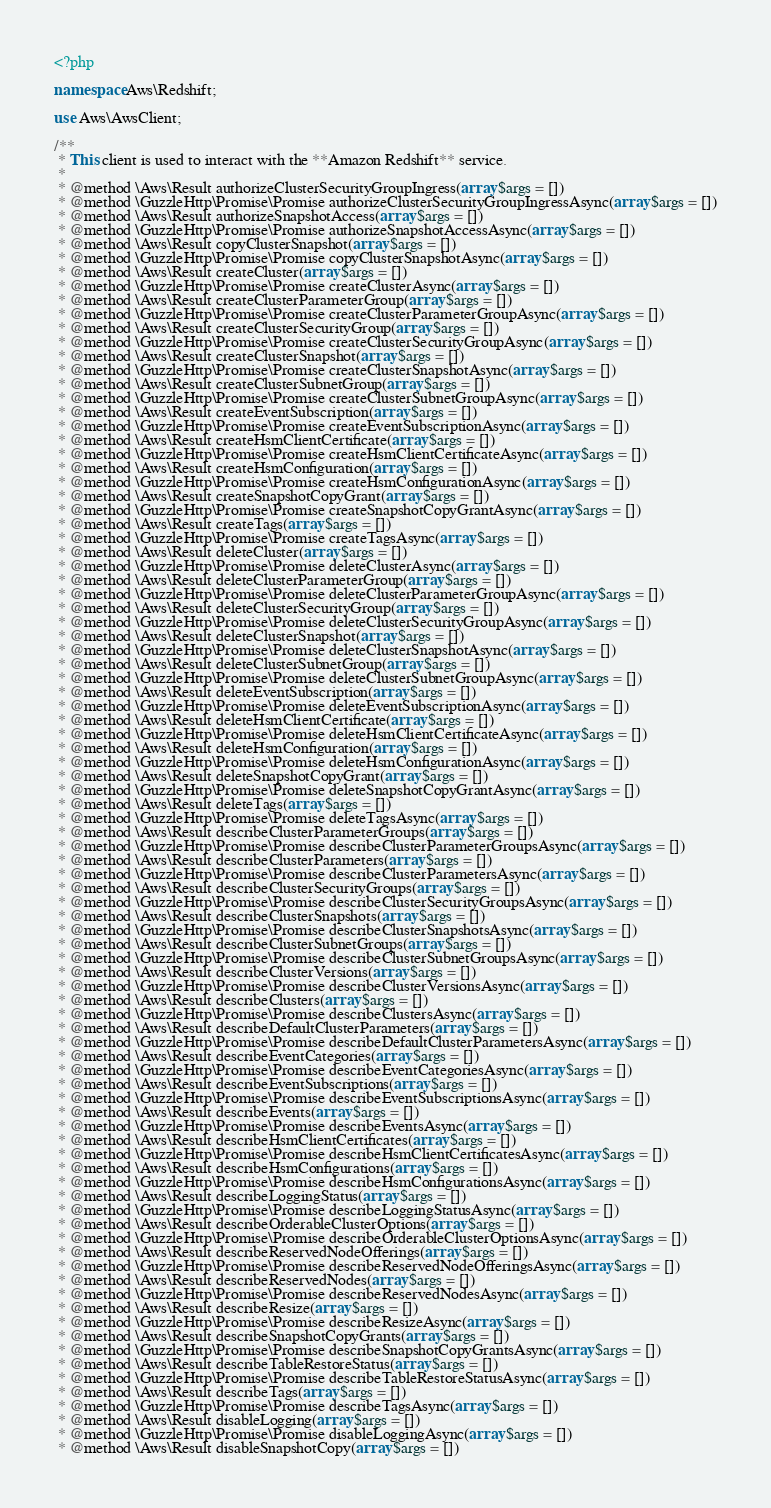Convert code to text. <code><loc_0><loc_0><loc_500><loc_500><_PHP_><?php

namespace Aws\Redshift;

use Aws\AwsClient;

/**
 * This client is used to interact with the **Amazon Redshift** service.
 *
 * @method \Aws\Result authorizeClusterSecurityGroupIngress(array $args = [])
 * @method \GuzzleHttp\Promise\Promise authorizeClusterSecurityGroupIngressAsync(array $args = [])
 * @method \Aws\Result authorizeSnapshotAccess(array $args = [])
 * @method \GuzzleHttp\Promise\Promise authorizeSnapshotAccessAsync(array $args = [])
 * @method \Aws\Result copyClusterSnapshot(array $args = [])
 * @method \GuzzleHttp\Promise\Promise copyClusterSnapshotAsync(array $args = [])
 * @method \Aws\Result createCluster(array $args = [])
 * @method \GuzzleHttp\Promise\Promise createClusterAsync(array $args = [])
 * @method \Aws\Result createClusterParameterGroup(array $args = [])
 * @method \GuzzleHttp\Promise\Promise createClusterParameterGroupAsync(array $args = [])
 * @method \Aws\Result createClusterSecurityGroup(array $args = [])
 * @method \GuzzleHttp\Promise\Promise createClusterSecurityGroupAsync(array $args = [])
 * @method \Aws\Result createClusterSnapshot(array $args = [])
 * @method \GuzzleHttp\Promise\Promise createClusterSnapshotAsync(array $args = [])
 * @method \Aws\Result createClusterSubnetGroup(array $args = [])
 * @method \GuzzleHttp\Promise\Promise createClusterSubnetGroupAsync(array $args = [])
 * @method \Aws\Result createEventSubscription(array $args = [])
 * @method \GuzzleHttp\Promise\Promise createEventSubscriptionAsync(array $args = [])
 * @method \Aws\Result createHsmClientCertificate(array $args = [])
 * @method \GuzzleHttp\Promise\Promise createHsmClientCertificateAsync(array $args = [])
 * @method \Aws\Result createHsmConfiguration(array $args = [])
 * @method \GuzzleHttp\Promise\Promise createHsmConfigurationAsync(array $args = [])
 * @method \Aws\Result createSnapshotCopyGrant(array $args = [])
 * @method \GuzzleHttp\Promise\Promise createSnapshotCopyGrantAsync(array $args = [])
 * @method \Aws\Result createTags(array $args = [])
 * @method \GuzzleHttp\Promise\Promise createTagsAsync(array $args = [])
 * @method \Aws\Result deleteCluster(array $args = [])
 * @method \GuzzleHttp\Promise\Promise deleteClusterAsync(array $args = [])
 * @method \Aws\Result deleteClusterParameterGroup(array $args = [])
 * @method \GuzzleHttp\Promise\Promise deleteClusterParameterGroupAsync(array $args = [])
 * @method \Aws\Result deleteClusterSecurityGroup(array $args = [])
 * @method \GuzzleHttp\Promise\Promise deleteClusterSecurityGroupAsync(array $args = [])
 * @method \Aws\Result deleteClusterSnapshot(array $args = [])
 * @method \GuzzleHttp\Promise\Promise deleteClusterSnapshotAsync(array $args = [])
 * @method \Aws\Result deleteClusterSubnetGroup(array $args = [])
 * @method \GuzzleHttp\Promise\Promise deleteClusterSubnetGroupAsync(array $args = [])
 * @method \Aws\Result deleteEventSubscription(array $args = [])
 * @method \GuzzleHttp\Promise\Promise deleteEventSubscriptionAsync(array $args = [])
 * @method \Aws\Result deleteHsmClientCertificate(array $args = [])
 * @method \GuzzleHttp\Promise\Promise deleteHsmClientCertificateAsync(array $args = [])
 * @method \Aws\Result deleteHsmConfiguration(array $args = [])
 * @method \GuzzleHttp\Promise\Promise deleteHsmConfigurationAsync(array $args = [])
 * @method \Aws\Result deleteSnapshotCopyGrant(array $args = [])
 * @method \GuzzleHttp\Promise\Promise deleteSnapshotCopyGrantAsync(array $args = [])
 * @method \Aws\Result deleteTags(array $args = [])
 * @method \GuzzleHttp\Promise\Promise deleteTagsAsync(array $args = [])
 * @method \Aws\Result describeClusterParameterGroups(array $args = [])
 * @method \GuzzleHttp\Promise\Promise describeClusterParameterGroupsAsync(array $args = [])
 * @method \Aws\Result describeClusterParameters(array $args = [])
 * @method \GuzzleHttp\Promise\Promise describeClusterParametersAsync(array $args = [])
 * @method \Aws\Result describeClusterSecurityGroups(array $args = [])
 * @method \GuzzleHttp\Promise\Promise describeClusterSecurityGroupsAsync(array $args = [])
 * @method \Aws\Result describeClusterSnapshots(array $args = [])
 * @method \GuzzleHttp\Promise\Promise describeClusterSnapshotsAsync(array $args = [])
 * @method \Aws\Result describeClusterSubnetGroups(array $args = [])
 * @method \GuzzleHttp\Promise\Promise describeClusterSubnetGroupsAsync(array $args = [])
 * @method \Aws\Result describeClusterVersions(array $args = [])
 * @method \GuzzleHttp\Promise\Promise describeClusterVersionsAsync(array $args = [])
 * @method \Aws\Result describeClusters(array $args = [])
 * @method \GuzzleHttp\Promise\Promise describeClustersAsync(array $args = [])
 * @method \Aws\Result describeDefaultClusterParameters(array $args = [])
 * @method \GuzzleHttp\Promise\Promise describeDefaultClusterParametersAsync(array $args = [])
 * @method \Aws\Result describeEventCategories(array $args = [])
 * @method \GuzzleHttp\Promise\Promise describeEventCategoriesAsync(array $args = [])
 * @method \Aws\Result describeEventSubscriptions(array $args = [])
 * @method \GuzzleHttp\Promise\Promise describeEventSubscriptionsAsync(array $args = [])
 * @method \Aws\Result describeEvents(array $args = [])
 * @method \GuzzleHttp\Promise\Promise describeEventsAsync(array $args = [])
 * @method \Aws\Result describeHsmClientCertificates(array $args = [])
 * @method \GuzzleHttp\Promise\Promise describeHsmClientCertificatesAsync(array $args = [])
 * @method \Aws\Result describeHsmConfigurations(array $args = [])
 * @method \GuzzleHttp\Promise\Promise describeHsmConfigurationsAsync(array $args = [])
 * @method \Aws\Result describeLoggingStatus(array $args = [])
 * @method \GuzzleHttp\Promise\Promise describeLoggingStatusAsync(array $args = [])
 * @method \Aws\Result describeOrderableClusterOptions(array $args = [])
 * @method \GuzzleHttp\Promise\Promise describeOrderableClusterOptionsAsync(array $args = [])
 * @method \Aws\Result describeReservedNodeOfferings(array $args = [])
 * @method \GuzzleHttp\Promise\Promise describeReservedNodeOfferingsAsync(array $args = [])
 * @method \Aws\Result describeReservedNodes(array $args = [])
 * @method \GuzzleHttp\Promise\Promise describeReservedNodesAsync(array $args = [])
 * @method \Aws\Result describeResize(array $args = [])
 * @method \GuzzleHttp\Promise\Promise describeResizeAsync(array $args = [])
 * @method \Aws\Result describeSnapshotCopyGrants(array $args = [])
 * @method \GuzzleHttp\Promise\Promise describeSnapshotCopyGrantsAsync(array $args = [])
 * @method \Aws\Result describeTableRestoreStatus(array $args = [])
 * @method \GuzzleHttp\Promise\Promise describeTableRestoreStatusAsync(array $args = [])
 * @method \Aws\Result describeTags(array $args = [])
 * @method \GuzzleHttp\Promise\Promise describeTagsAsync(array $args = [])
 * @method \Aws\Result disableLogging(array $args = [])
 * @method \GuzzleHttp\Promise\Promise disableLoggingAsync(array $args = [])
 * @method \Aws\Result disableSnapshotCopy(array $args = [])</code> 